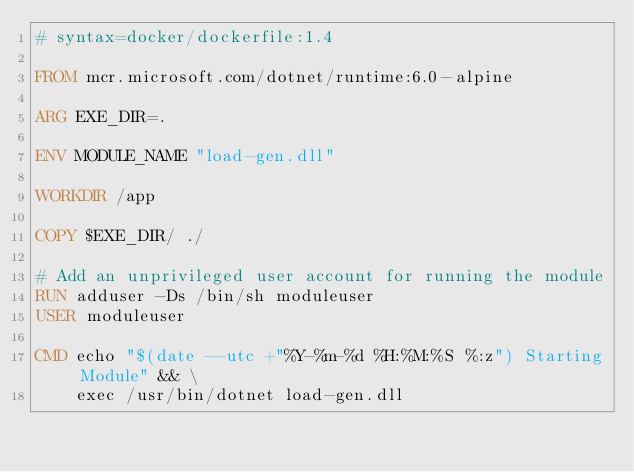<code> <loc_0><loc_0><loc_500><loc_500><_Dockerfile_># syntax=docker/dockerfile:1.4

FROM mcr.microsoft.com/dotnet/runtime:6.0-alpine

ARG EXE_DIR=.

ENV MODULE_NAME "load-gen.dll"

WORKDIR /app

COPY $EXE_DIR/ ./

# Add an unprivileged user account for running the module
RUN adduser -Ds /bin/sh moduleuser 
USER moduleuser

CMD echo "$(date --utc +"%Y-%m-%d %H:%M:%S %:z") Starting Module" && \
    exec /usr/bin/dotnet load-gen.dll
</code> 